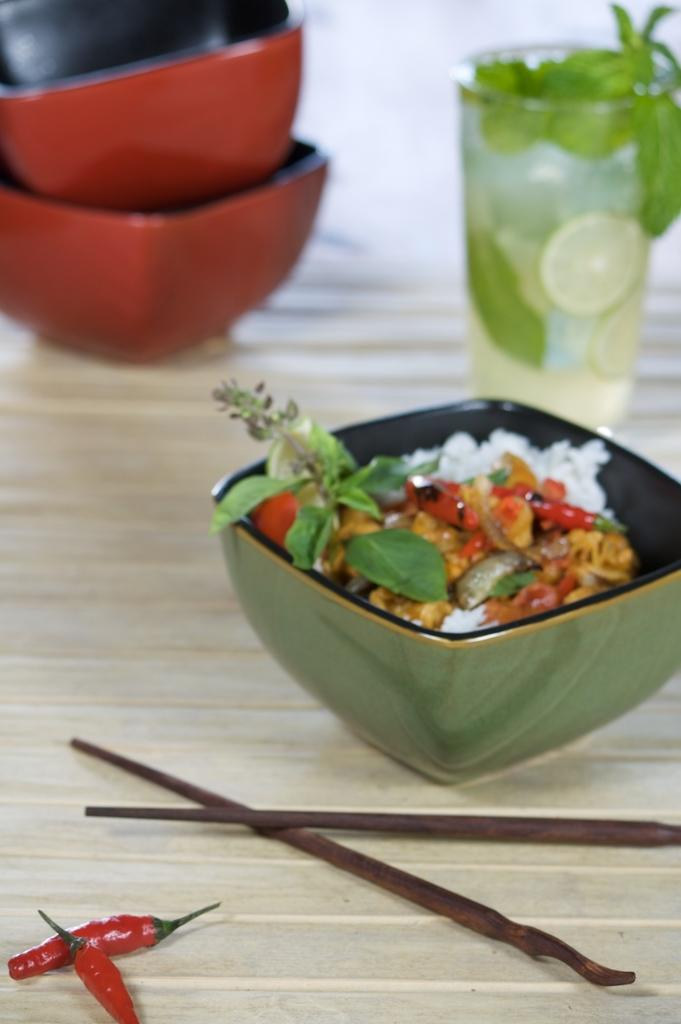What piece of furniture is in the image? There is a table in the image. What can be found on the table? There are bowls, a glass of drink, chopsticks, red chillies, and food in a bowl on the table. What type of utensil is present on the table? Chopsticks are present on the table. What is the food in the bowl made of? The food in the bowl is not specified, but it is visible on the table. How many rabbits are hopping around the table in the image? There are no rabbits present in the image; it only features a table with various items on it. What type of cough medicine is visible on the table in the image? There is no cough medicine present in the image; it only features a table with various items on it. 